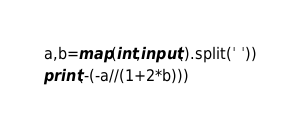Convert code to text. <code><loc_0><loc_0><loc_500><loc_500><_Python_>a,b=map(int,input().split(' '))
print(-(-a//(1+2*b)))
</code> 